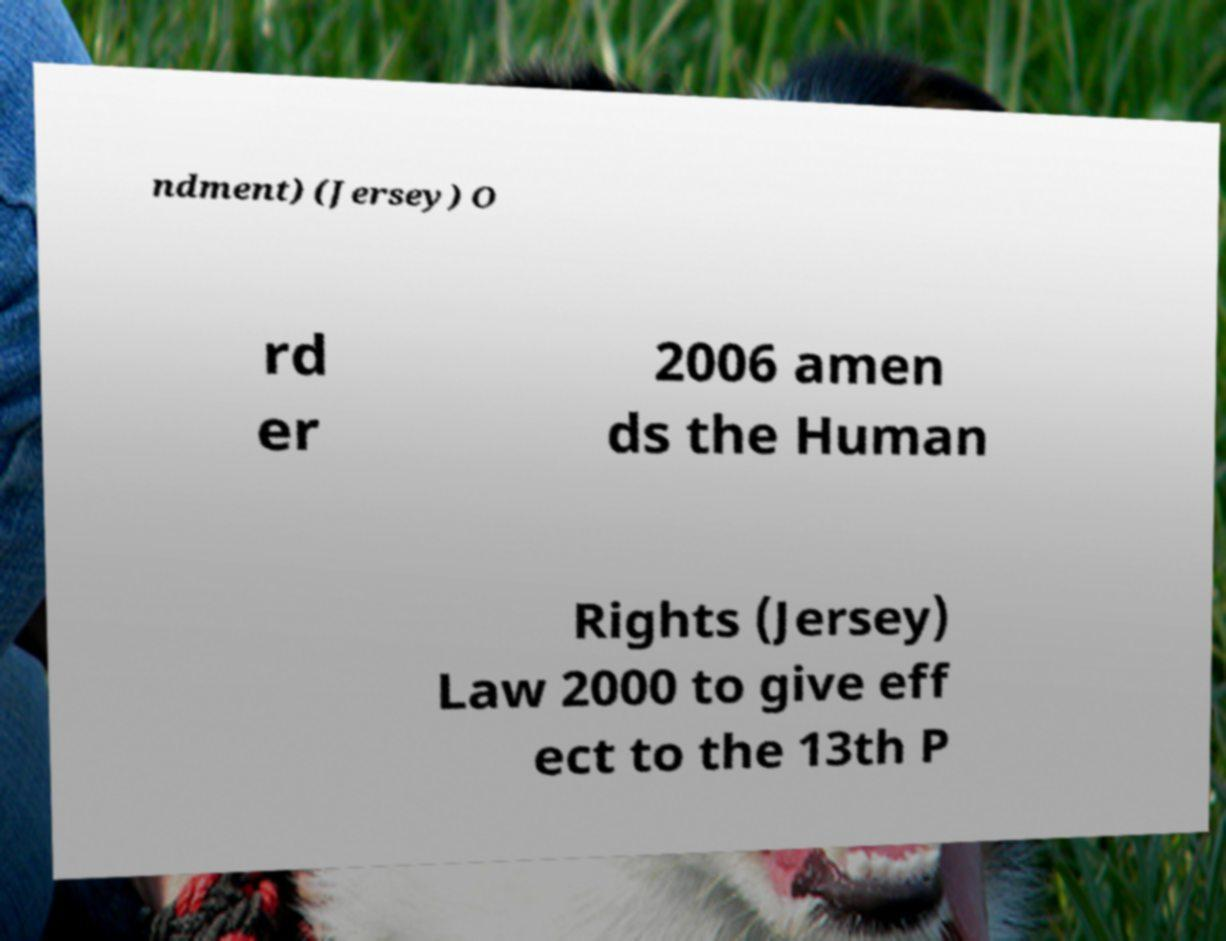Can you read and provide the text displayed in the image?This photo seems to have some interesting text. Can you extract and type it out for me? ndment) (Jersey) O rd er 2006 amen ds the Human Rights (Jersey) Law 2000 to give eff ect to the 13th P 